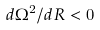<formula> <loc_0><loc_0><loc_500><loc_500>d \Omega ^ { 2 } / d R < 0</formula> 